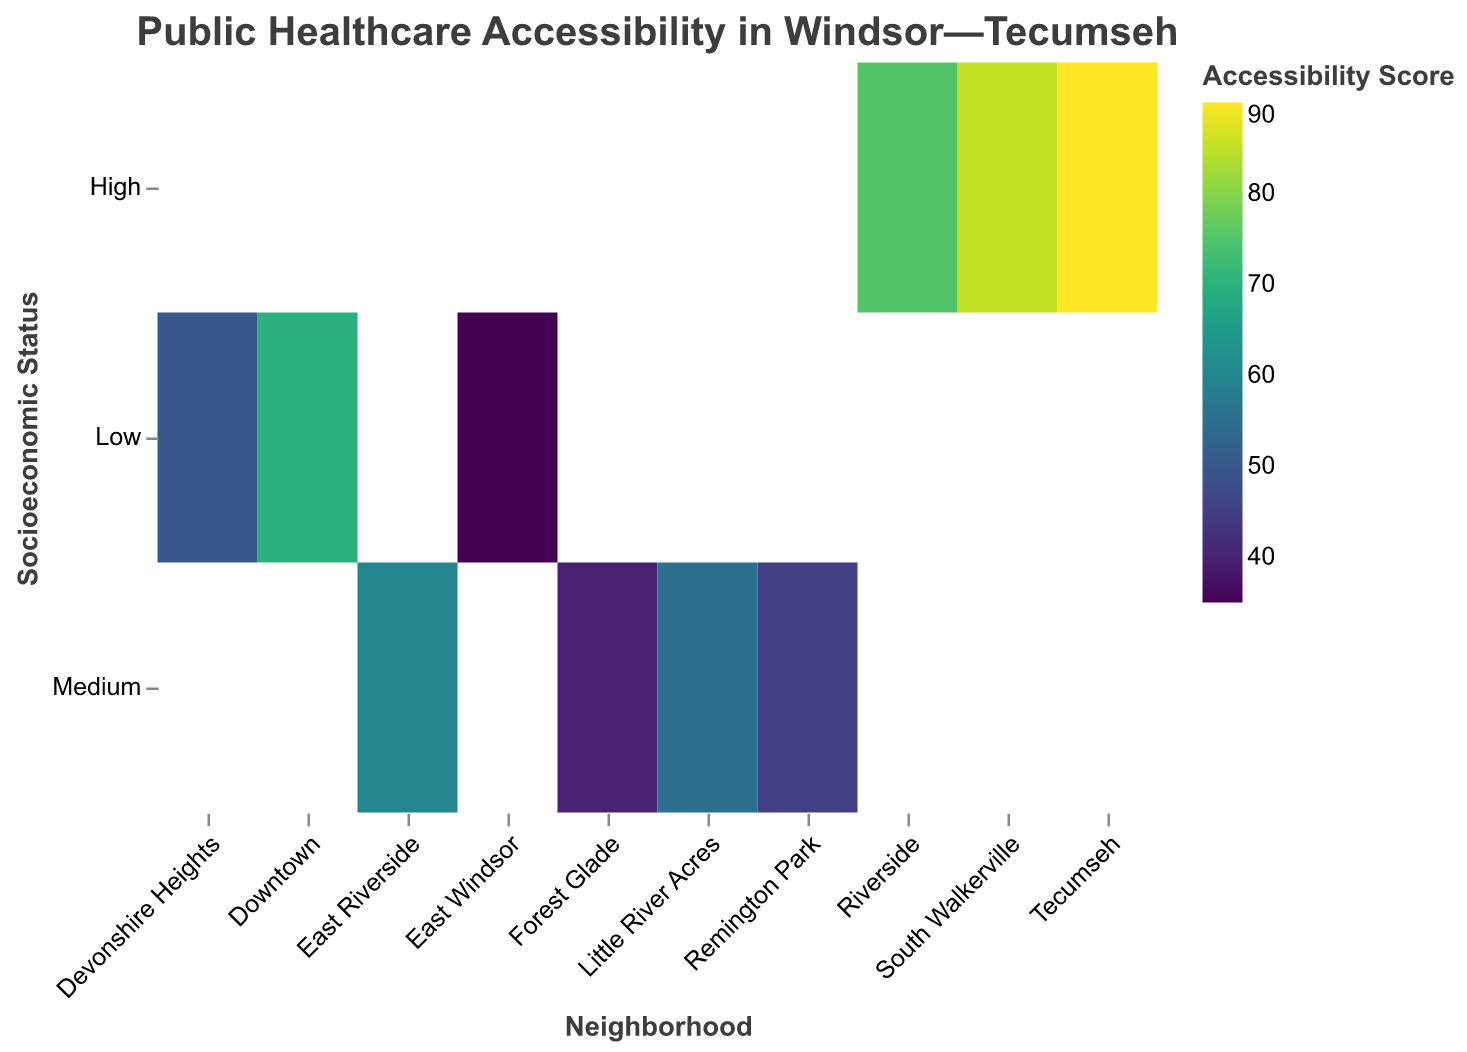What's the title of the heatmap? The heatmap's title can be read at the top of the plot, indicating what data is being visualized.
Answer: Public Healthcare Accessibility in Windsor—Tecumseh Which neighborhood has the highest accessibility score? By looking at the color intensity and referring to the legend, Tecumseh has the darkest color corresponding to the highest score.
Answer: Tecumseh What is the accessibility score for East Riverside? Find East Riverside on the x-axis and locate the corresponding color; check the color against the legend.
Answer: 60 How many healthcare centers are there in South Walkerville? Hovering over or referring to the tooltip information for South Walkerville will provide this number directly.
Answer: 4 Compare the accessibility scores of Riverside and Little River Acres. Which is higher and by how much? Riverside has an accessibility score of 75 while Little River Acres has 55. The difference can be calculated by subtracting 55 from 75.
Answer: Riverside; 20 Which neighborhoods with medium socioeconomic status have at least 2 healthcare centers? Checking the y-axis for 'Medium' and then cross-referencing with the healthcare center counts, we find East Riverside and Little River Acres.
Answer: East Riverside, Little River Acres Which neighborhood has the lowest accessibility score and what is its socioeconomic status? The lightest color indicates the lowest score, which corresponds to East Windsor with a score of 35 and a low socioeconomic status.
Answer: East Windsor; Low 